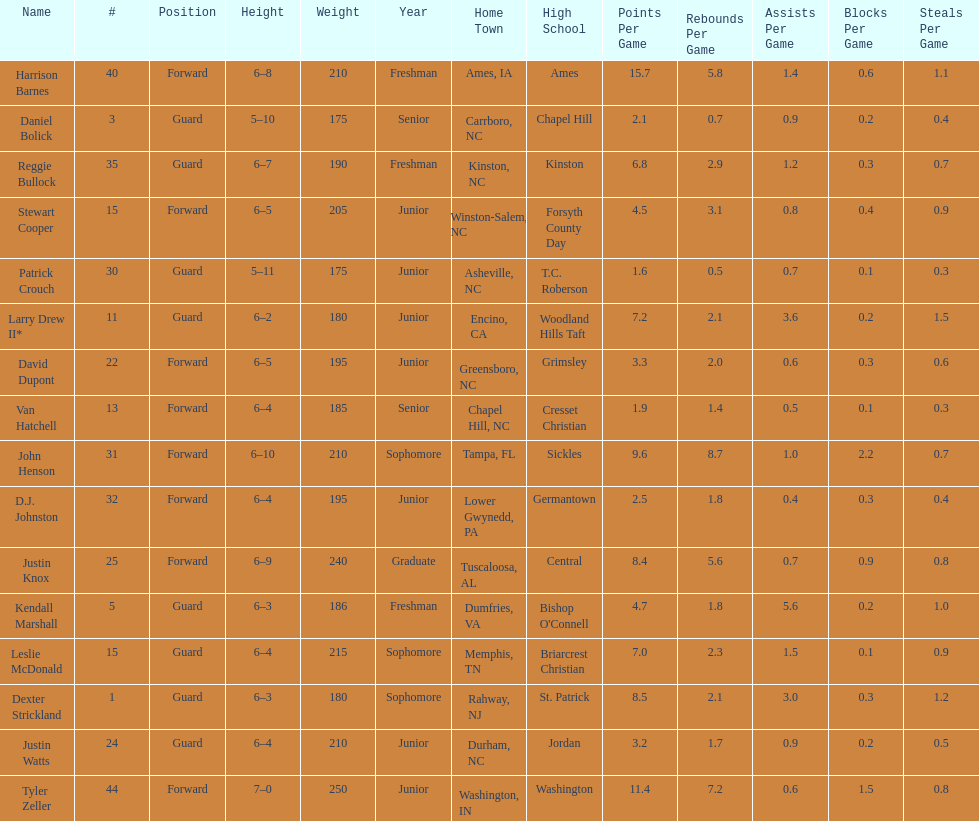How many players are there with a weight of over 200? 7. 